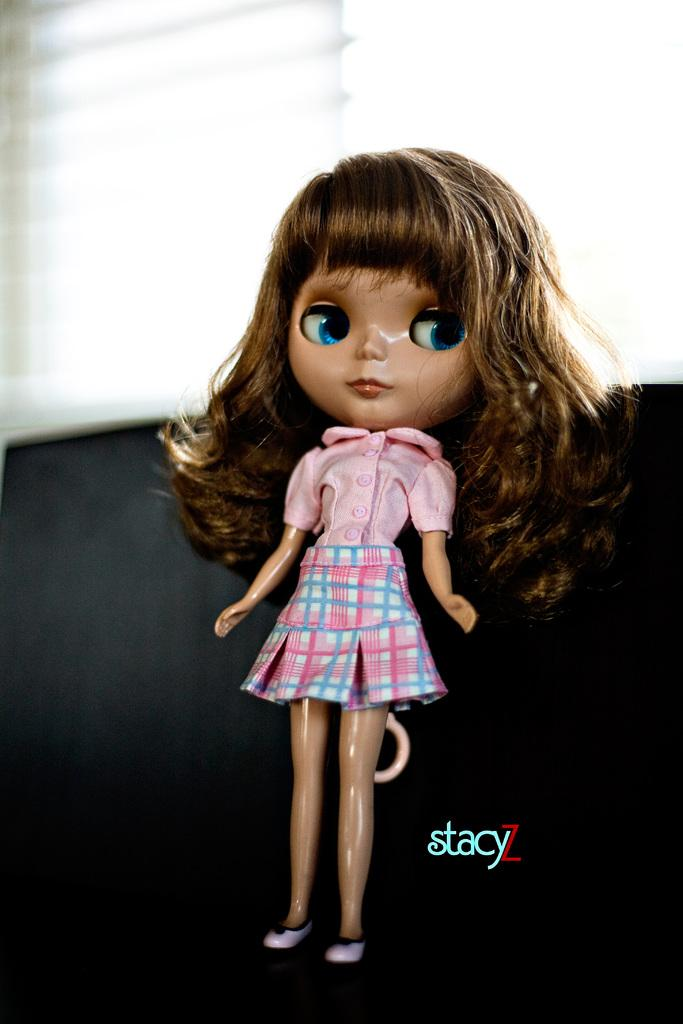What is the main subject of the image? There is a doll in the image. What colors are used in the background of the image? The background of the image is white and black. What is the doll's opinion on the current political climate in the image? The image does not provide any information about the doll's opinion on the current political climate, as it is a static image of a doll. 